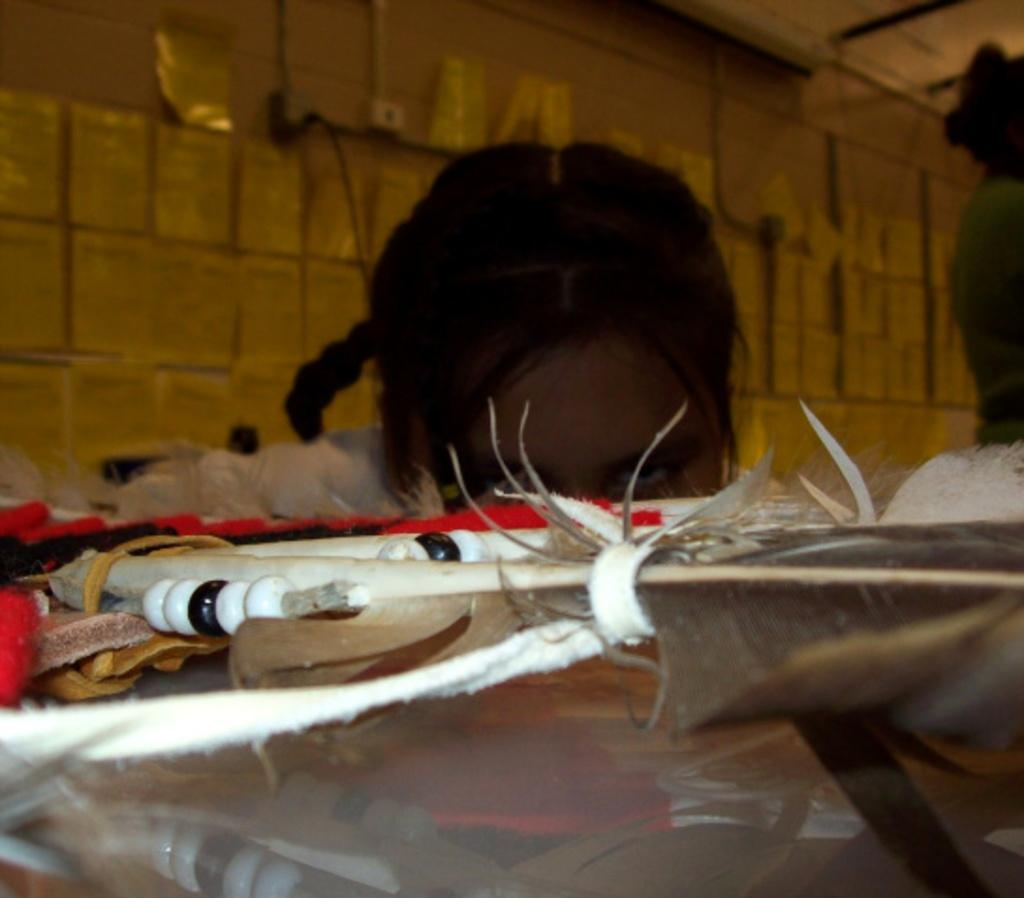Who is the main subject in the image? There is a girl in the center of the image. What is in front of the girl? There are many objects in front of the girl. What can be seen behind the girl? There is a wall in the background of the image. How many ladybugs are on the girl's shoulder in the image? There are no ladybugs present in the image. 